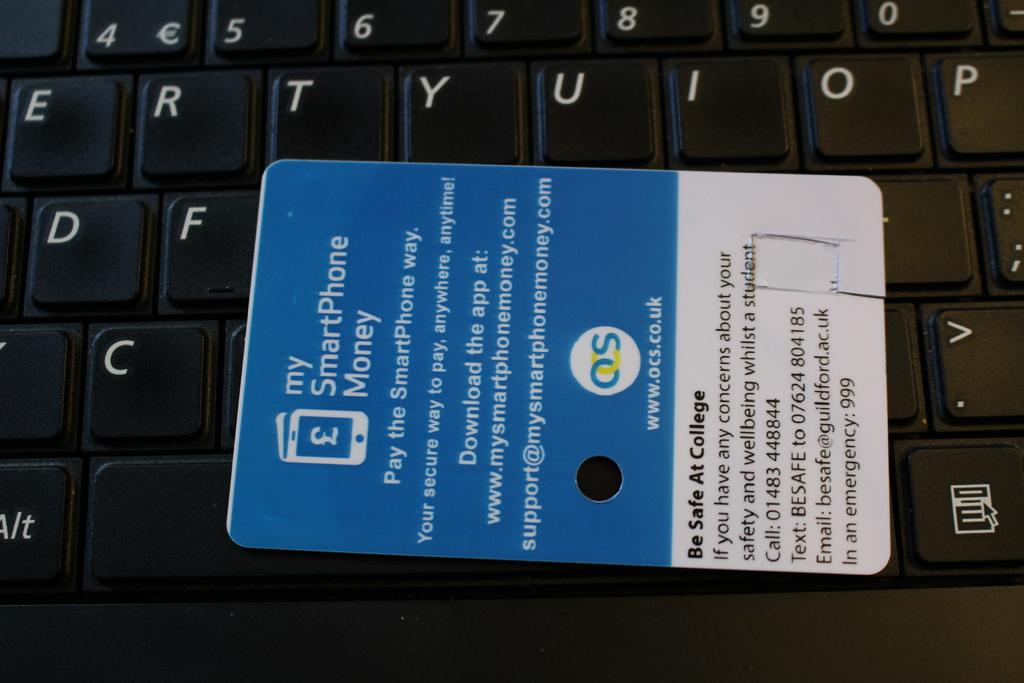<image>
Write a terse but informative summary of the picture. An advertising card for My SmartPhone Money, sponsored by OCS. 